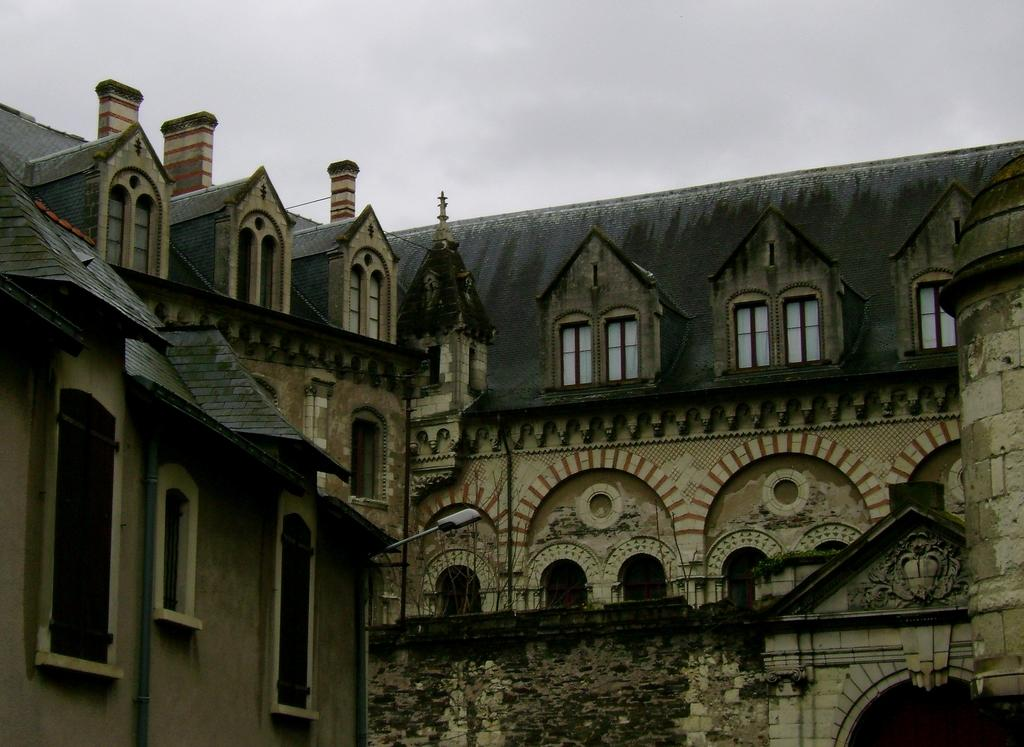What is the main subject of the image? The main subject of the image is a building. Can you describe the building in the image? The building has windows. What else can be seen in the image besides the building? There is a lamp pole in the image. What is visible at the top of the image? The sky is visible at the top of the image. What type of wine is being served at the event in the image? There is no event or wine present in the image; it features a building with windows and a lamp pole. How much debt is visible on the building in the image? There is no indication of debt on the building in the image. 